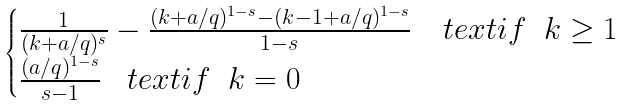Convert formula to latex. <formula><loc_0><loc_0><loc_500><loc_500>\begin{cases} \frac { 1 } { ( k + a / q ) ^ { s } } - \frac { ( k + a / q ) ^ { 1 - s } - ( k - 1 + a / q ) ^ { 1 - s } } { 1 - s } \quad t e x t { i f } \ \ k \geq 1 \\ \frac { ( a / q ) ^ { 1 - s } } { s - 1 } \ \ \ t e x t { i f } \ \ k = 0 \end{cases}</formula> 